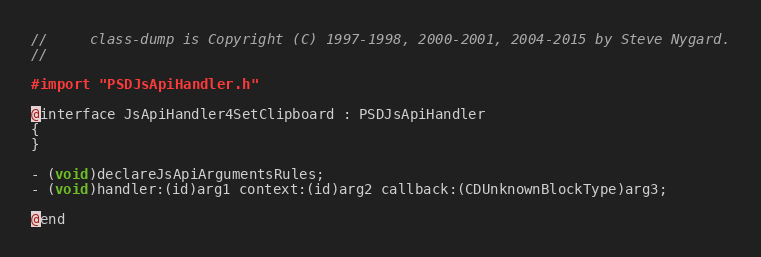<code> <loc_0><loc_0><loc_500><loc_500><_C_>//     class-dump is Copyright (C) 1997-1998, 2000-2001, 2004-2015 by Steve Nygard.
//

#import "PSDJsApiHandler.h"

@interface JsApiHandler4SetClipboard : PSDJsApiHandler
{
}

- (void)declareJsApiArgumentsRules;
- (void)handler:(id)arg1 context:(id)arg2 callback:(CDUnknownBlockType)arg3;

@end

</code> 